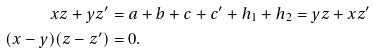Convert formula to latex. <formula><loc_0><loc_0><loc_500><loc_500>x z + y z ^ { \prime } & = a + b + c + c ^ { \prime } + h _ { 1 } + h _ { 2 } = y z + x z ^ { \prime } \\ ( x - y ) ( z - z ^ { \prime } ) & = 0 .</formula> 